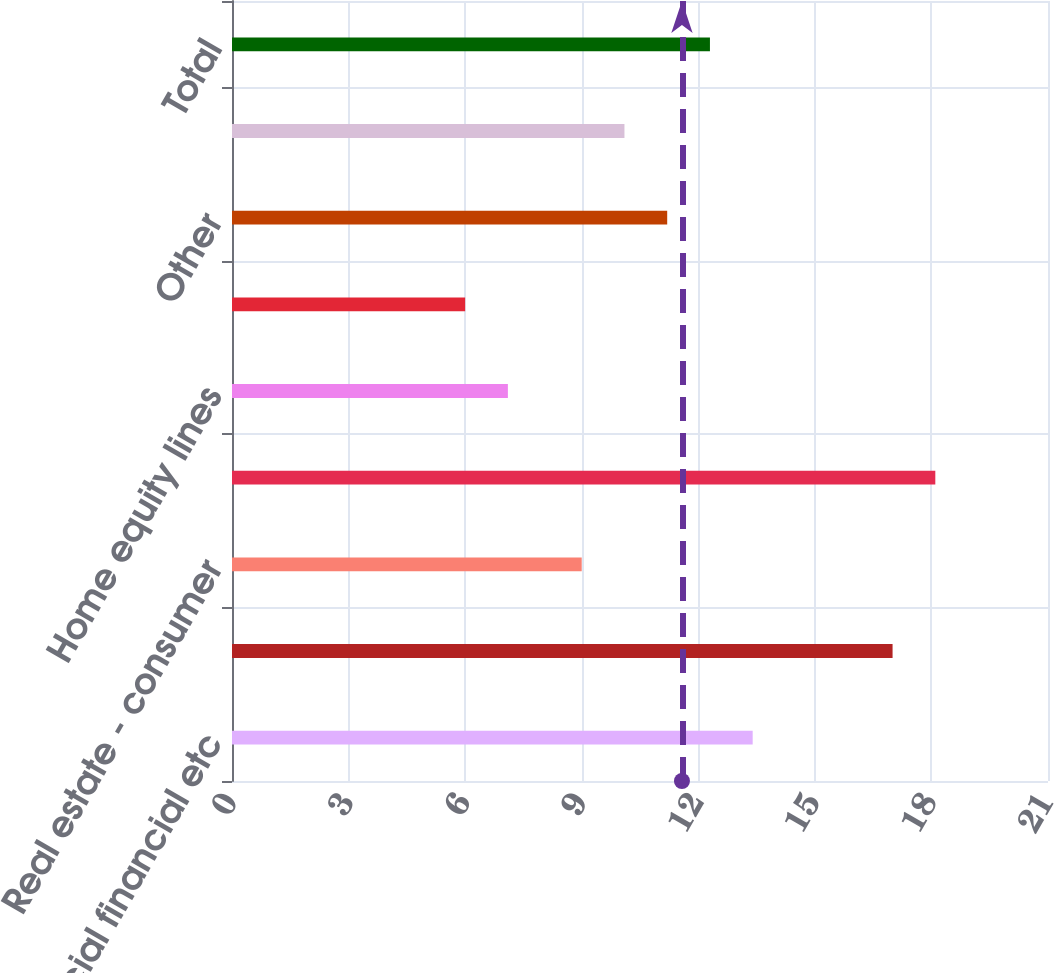Convert chart to OTSL. <chart><loc_0><loc_0><loc_500><loc_500><bar_chart><fcel>Commercial financial etc<fcel>Real estate - commercial<fcel>Real estate - consumer<fcel>Automobile<fcel>Home equity lines<fcel>Home equity loans<fcel>Other<fcel>Total consumer<fcel>Total<nl><fcel>13.4<fcel>17<fcel>9<fcel>18.1<fcel>7.1<fcel>6<fcel>11.2<fcel>10.1<fcel>12.3<nl></chart> 